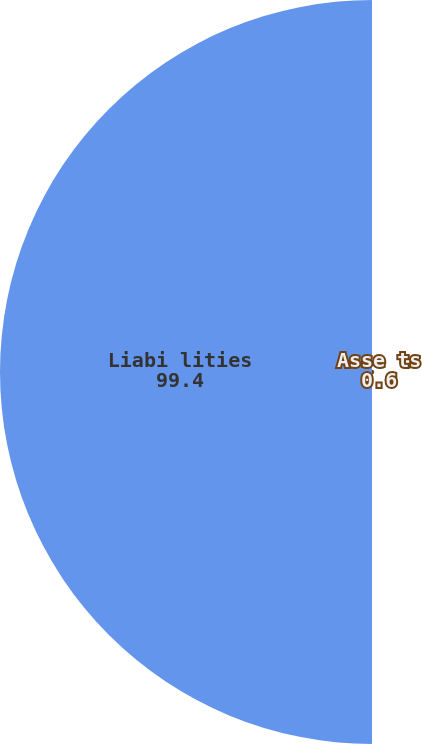<chart> <loc_0><loc_0><loc_500><loc_500><pie_chart><fcel>Asse ts<fcel>Liabi lities<nl><fcel>0.6%<fcel>99.4%<nl></chart> 